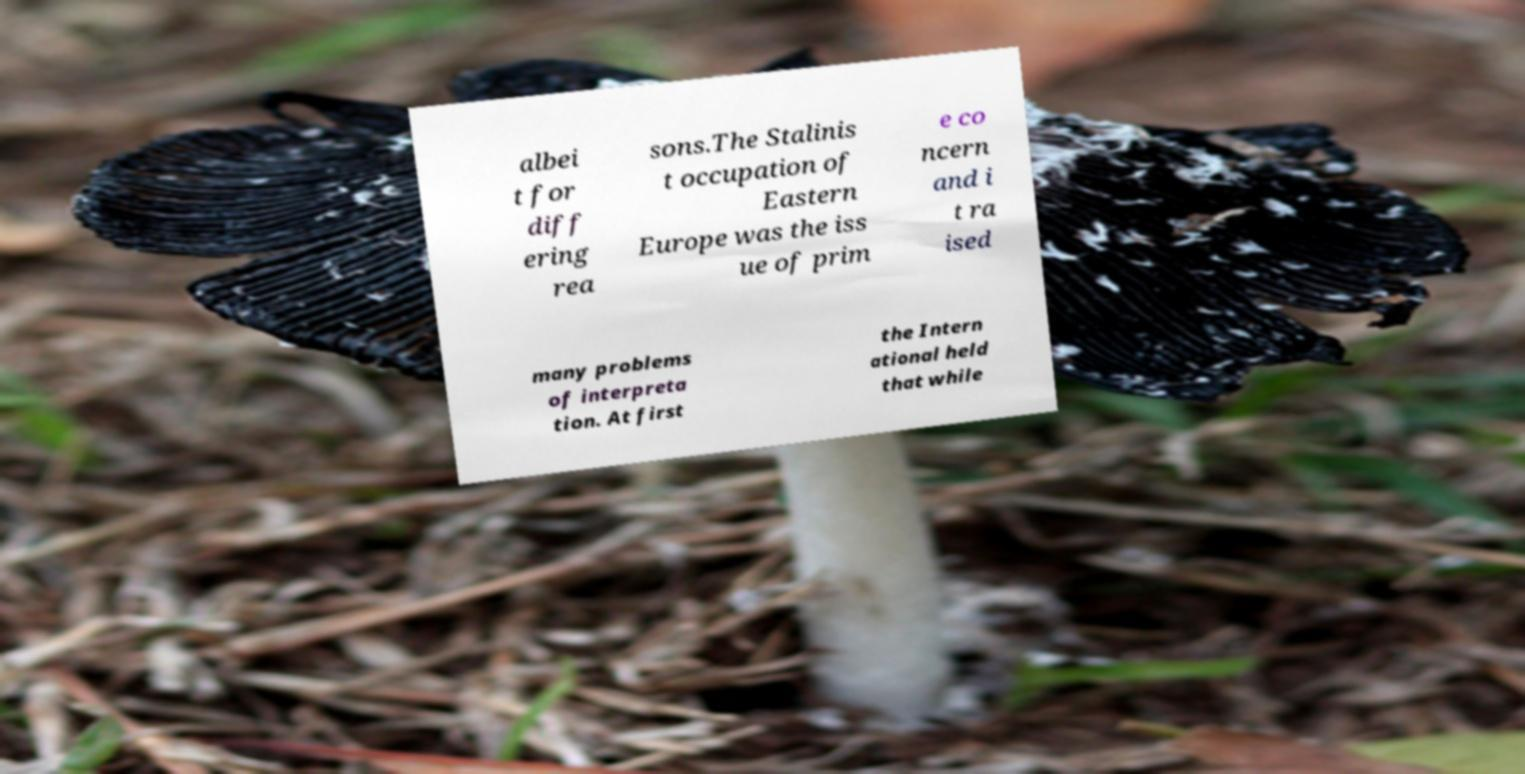Could you assist in decoding the text presented in this image and type it out clearly? albei t for diff ering rea sons.The Stalinis t occupation of Eastern Europe was the iss ue of prim e co ncern and i t ra ised many problems of interpreta tion. At first the Intern ational held that while 